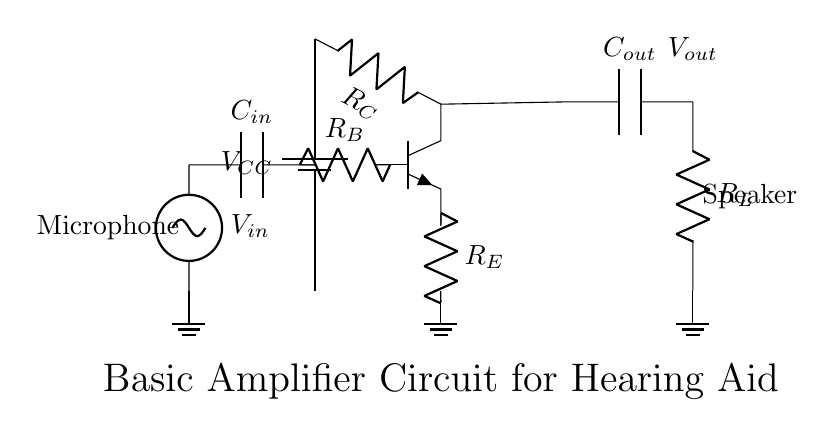What is the power supply voltage in this circuit? The power supply voltage is denoted as V_CC, which is typically the source voltage for the circuit. In a basic hearing aid circuit, it can usually be around 1.5V to 9V depending on the design, but it is explicitly labeled in the circuit.
Answer: V_CC What kind of transistor is used in this circuit? The circuit shows an NPN transistor (noted as npn in the diagram), which is commonly used for amplification purposes in hearing aids due to its ability to control a larger current.
Answer: NPN What is the purpose of the input capacitor? The input capacitor, labeled as C_in, serves to block any DC voltage from the input source while allowing AC signals (sound) to pass through. This is important for audio signals to be amplified without shifting the DC bias of the circuit.
Answer: Block DC What role does the resistor R_E play in this circuit? The emitter resistor R_E is used to stabilize the operating point of the transistor and to provide negative feedback, which helps to improve linearity and reduce distortion in the amplified signal.
Answer: Stabilization What is the behavior of V_out when V_in is increased? When V_in increases, it increases the base current of the transistor, leading to a proportional increase in collector current, thus causing V_out to rise as well, as long as the transistor remains in the active region.
Answer: Increases How does the value of R_C affect the output voltage? R_C affects the voltage drop across the collector resistor: a higher resistance will cause a greater drop for the same collector current, affecting the output voltage V_out, leading to a possible reduction. In contrast, a lower resistor value may yield a higher output voltage.
Answer: Affects V_out What type of load is connected at the output? The load connected at the output is indicated as R_L, which typically represents a speaker in hearing aid circuits. This resistor dissipates the amplified audio signal generated by the circuit.
Answer: Speaker 